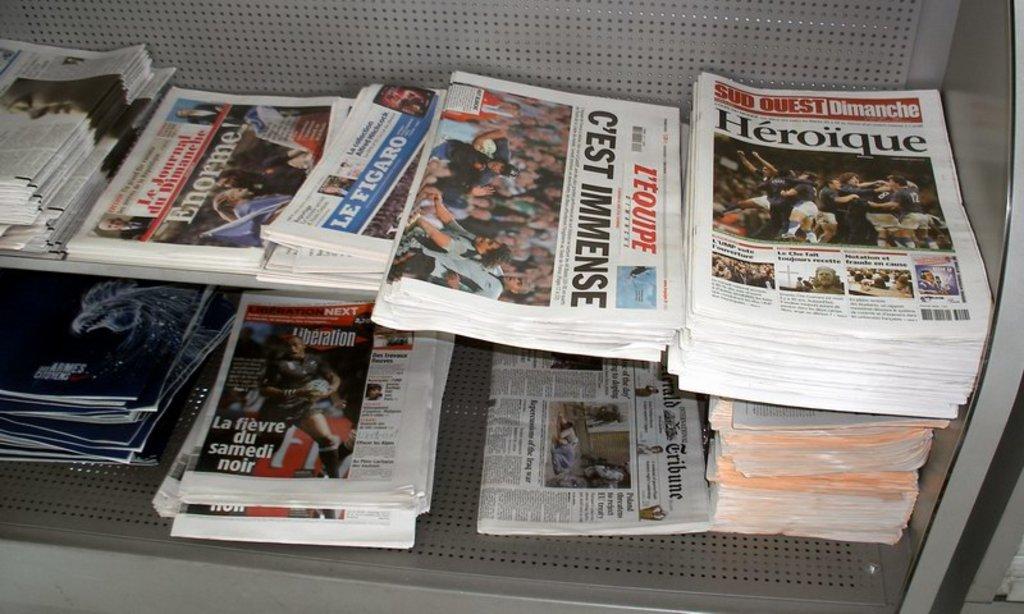What is the name of the paper on the right?
Provide a short and direct response. Heroique. What is the name of the newspaper?
Keep it short and to the point. L'equipe. 